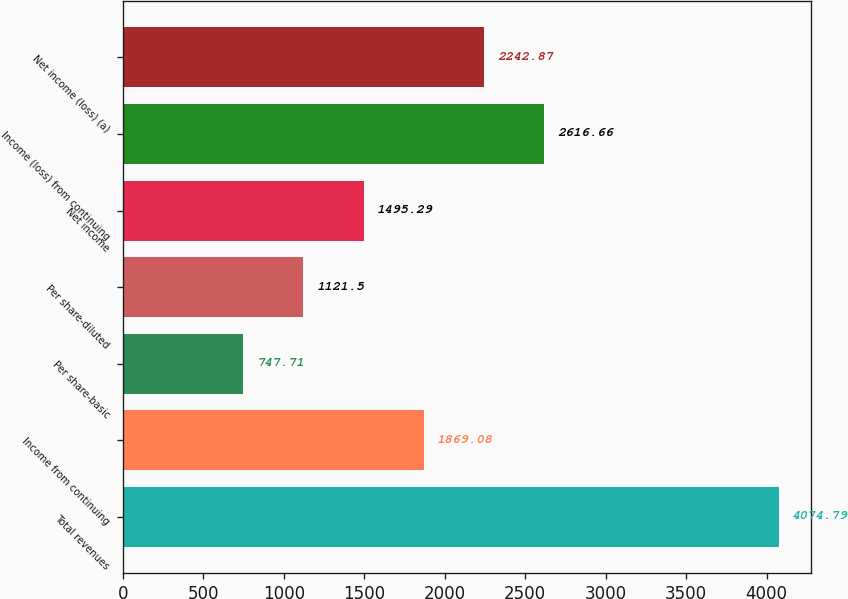Convert chart to OTSL. <chart><loc_0><loc_0><loc_500><loc_500><bar_chart><fcel>Total revenues<fcel>Income from continuing<fcel>Per share-basic<fcel>Per share-diluted<fcel>Net income<fcel>Income (loss) from continuing<fcel>Net income (loss) (a)<nl><fcel>4074.79<fcel>1869.08<fcel>747.71<fcel>1121.5<fcel>1495.29<fcel>2616.66<fcel>2242.87<nl></chart> 